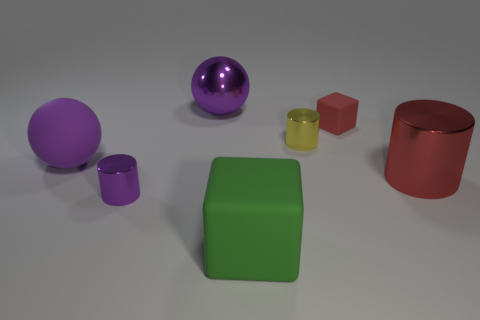Add 1 metallic things. How many objects exist? 8 Subtract all spheres. How many objects are left? 5 Subtract all green rubber things. Subtract all tiny purple metal things. How many objects are left? 5 Add 2 tiny purple things. How many tiny purple things are left? 3 Add 7 small rubber cylinders. How many small rubber cylinders exist? 7 Subtract 0 yellow balls. How many objects are left? 7 